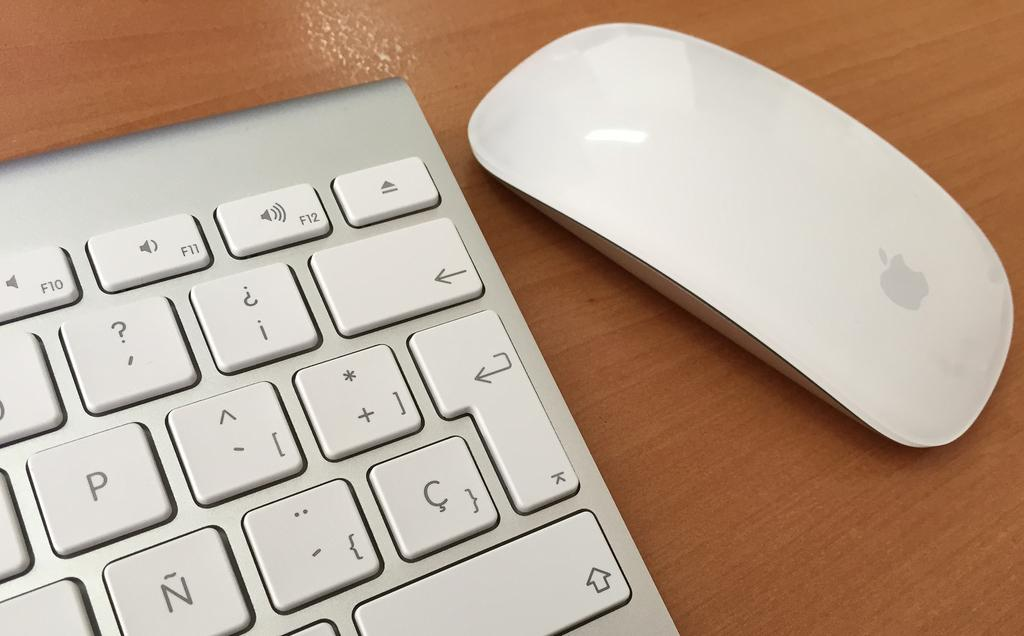What type of device is visible in the image? There is a keyboard in the image. What other device is present in the image? There is a mouse in the image. On what surface are the keyboard and mouse placed? Both the keyboard and mouse are on a wooden surface. What can be seen on the keyboard? The keyboard has visible letters, symbols, and keys. What is visible on the mouse? The mouse has a visible logo. What type of brush is used to paint the fiction novel on the wooden surface? There is no brush or fiction novel present in the image; it features a keyboard and mouse on a wooden surface. 